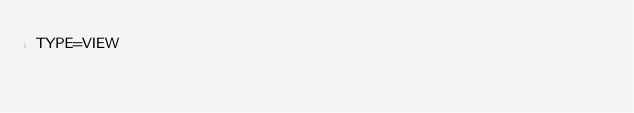Convert code to text. <code><loc_0><loc_0><loc_500><loc_500><_VisualBasic_>TYPE=VIEW</code> 